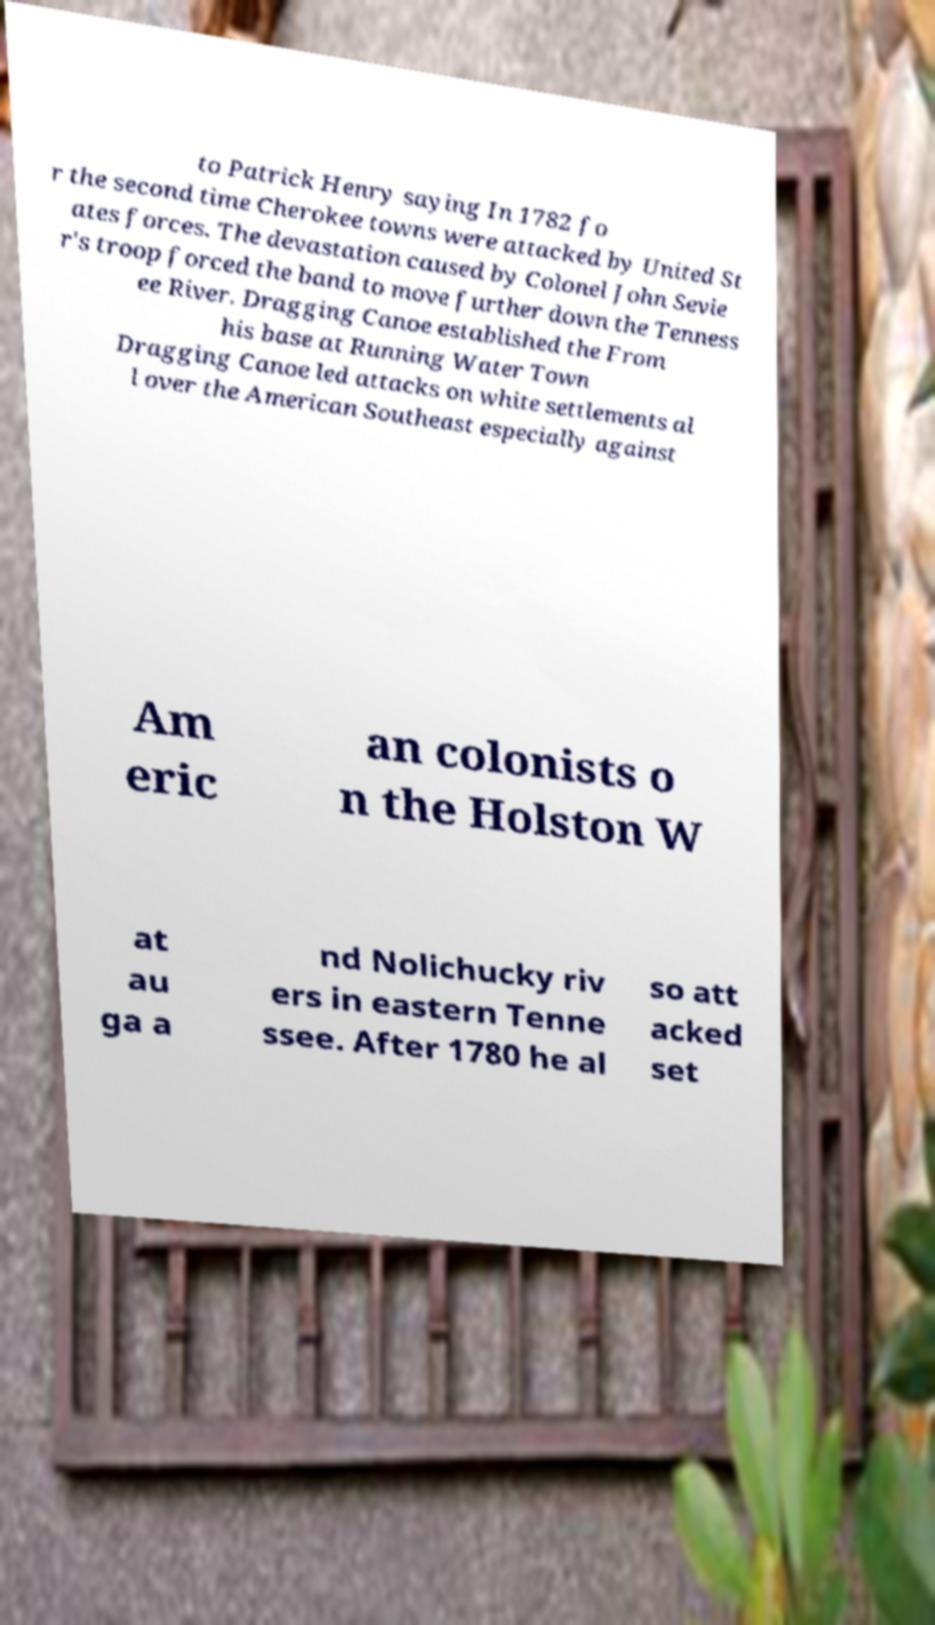Please identify and transcribe the text found in this image. to Patrick Henry saying In 1782 fo r the second time Cherokee towns were attacked by United St ates forces. The devastation caused by Colonel John Sevie r's troop forced the band to move further down the Tenness ee River. Dragging Canoe established the From his base at Running Water Town Dragging Canoe led attacks on white settlements al l over the American Southeast especially against Am eric an colonists o n the Holston W at au ga a nd Nolichucky riv ers in eastern Tenne ssee. After 1780 he al so att acked set 